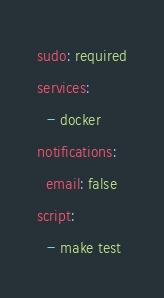<code> <loc_0><loc_0><loc_500><loc_500><_YAML_>sudo: required
services:
  - docker
notifications:
  email: false
script:
  - make test
</code> 